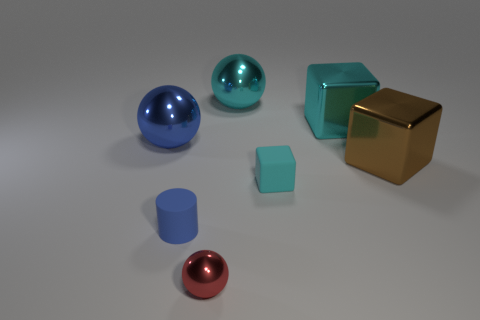Add 1 small cyan blocks. How many objects exist? 8 Subtract all cylinders. How many objects are left? 6 Add 3 red balls. How many red balls are left? 4 Add 4 cyan objects. How many cyan objects exist? 7 Subtract 0 green balls. How many objects are left? 7 Subtract all big gray rubber spheres. Subtract all big cyan spheres. How many objects are left? 6 